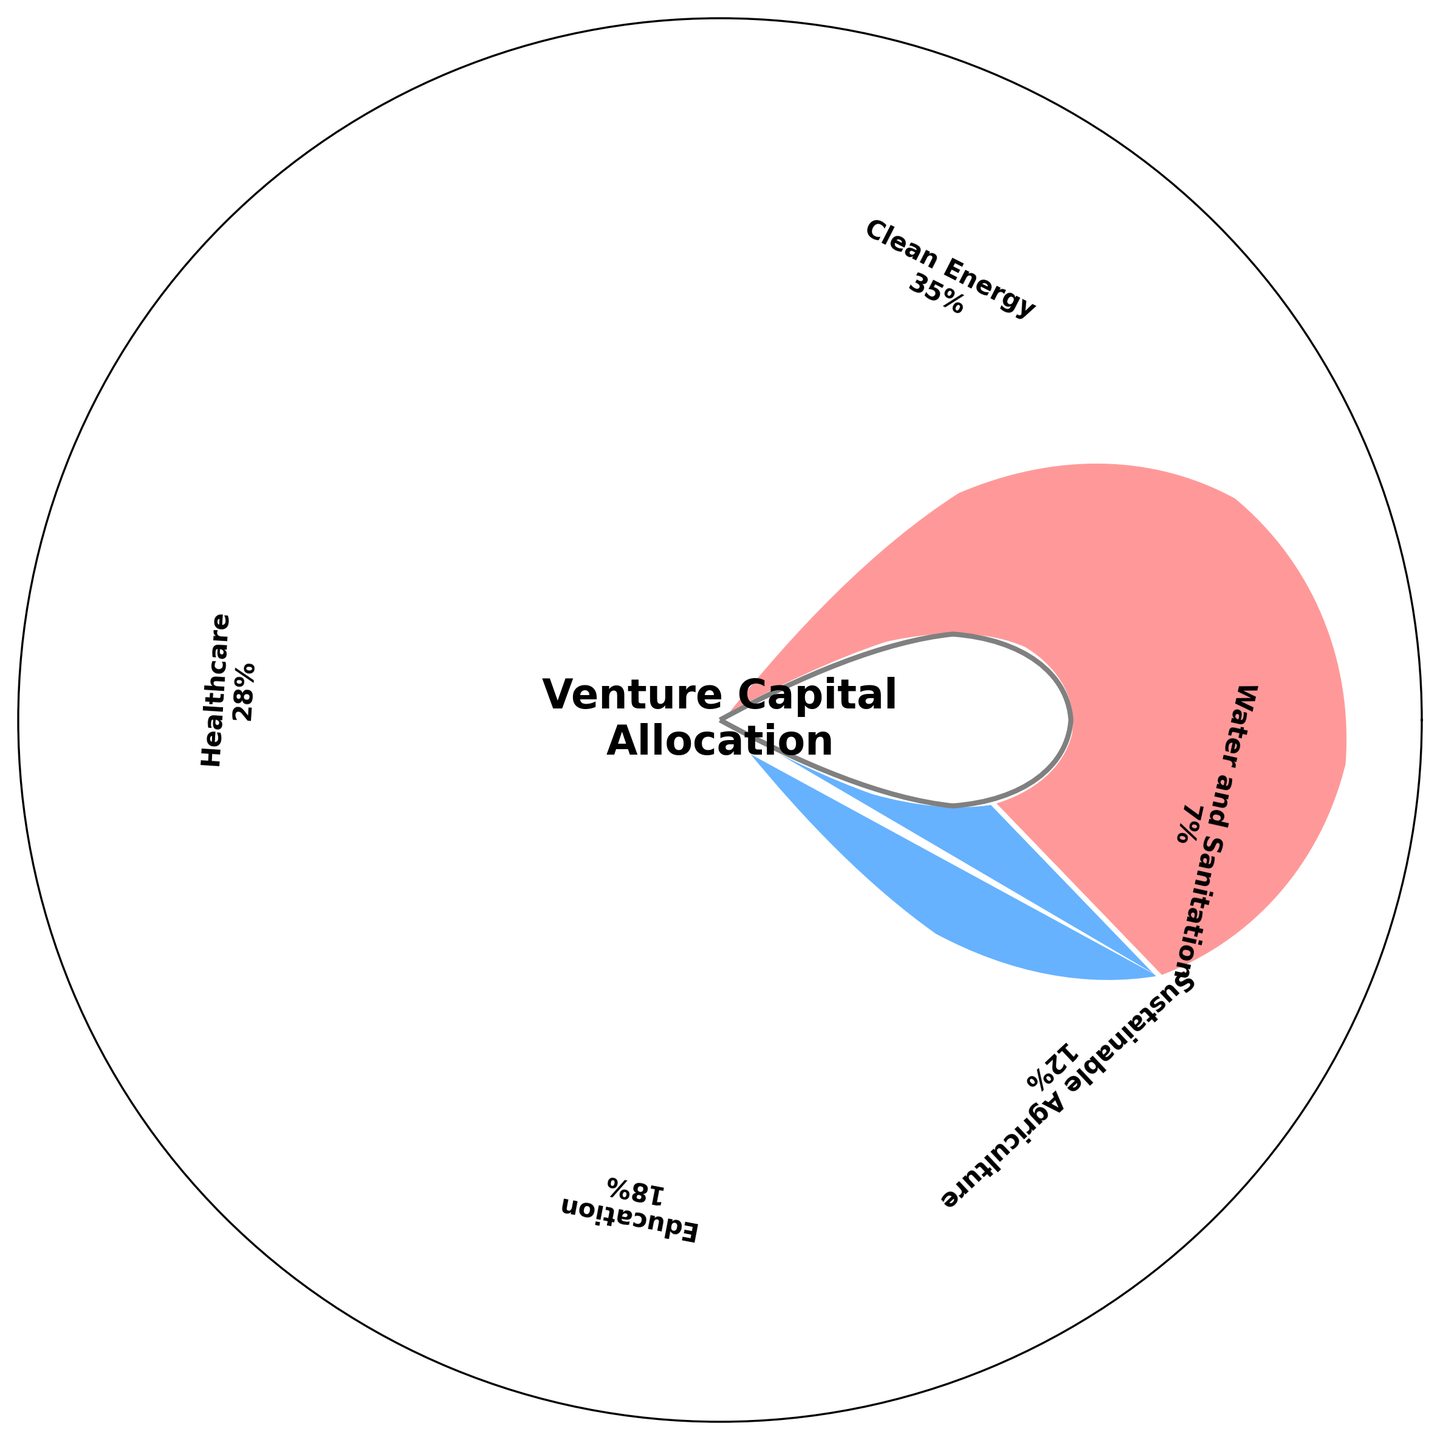What is the title of the gauge chart? The title is displayed in the center of the chart, inside the central circle. It reads "Venture Capital Allocation".
Answer: Venture Capital Allocation Which sector has the highest percentage of venture capital allocated? By examining the sector labels and their corresponding percentages, the Clean Energy sector has the highest allocation at 35%.
Answer: Clean Energy What is the percentage allocation for the Healthcare sector? The Healthcare sector's label shows a percentage of 28%.
Answer: 28% How many sectors are represented in the gauge chart? Counting the sector labels around the chart, there are five sectors represented.
Answer: 5 What percentage of venture capital is allocated to sectors other than Clean Energy and Healthcare combined? Adding the percentages of Education, Sustainable Agriculture, and Water and Sanitation: 18% (Education) + 12% (Sustainable Agriculture) + 7% (Water and Sanitation) = 37%.
Answer: 37% Which sector has the lowest percentage of venture capital allocated, and what is that percentage? The sector with the lowest percentage is Water and Sanitation, shown to be 7% on the chart.
Answer: Water and Sanitation, 7% Compare the allocation between Education and Sustainable Agriculture sectors. Which one has a higher allocation and by how much? Education is allocated 18% and Sustainable Agriculture 12%. The difference is 18% - 12% = 6%.
Answer: Education by 6% What percentage of venture capital is allocated to Clean Energy and Sustainable Agriculture combined? Adding the percentages of Clean Energy and Sustainable Agriculture: 35% + 12% = 47%.
Answer: 47% If the total venture capital is considered as 100%, what is the combined allocation for the sectors getting below 20%? Education, Sustainable Agriculture, and Water and Sanitation have percentages below 20%. Their combined allocation is 18% + 12% + 7% = 37%.
Answer: 37% Which sector is the second highest in venture capital allocation, and what is its percentage? The Healthcare sector is the second highest, allocated at 28%, following Clean Energy at 35%.
Answer: Healthcare, 28% 